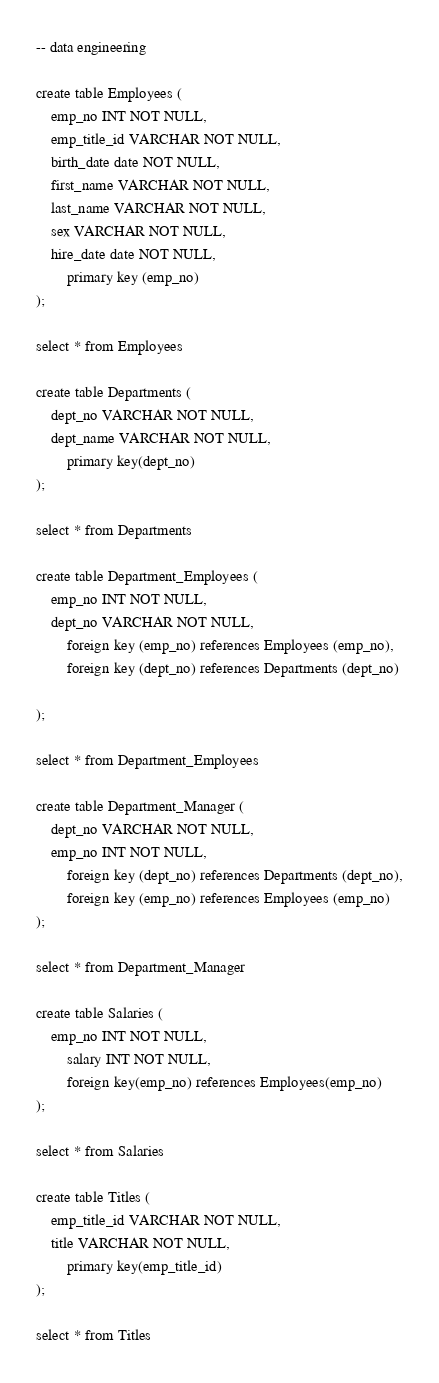Convert code to text. <code><loc_0><loc_0><loc_500><loc_500><_SQL_>-- data engineering

create table Employees (
	emp_no INT NOT NULL,
	emp_title_id VARCHAR NOT NULL,
	birth_date date NOT NULL,
	first_name VARCHAR NOT NULL,
	last_name VARCHAR NOT NULL,
	sex VARCHAR NOT NULL,
	hire_date date NOT NULL,
		primary key (emp_no)
);

select * from Employees

create table Departments (
	dept_no VARCHAR NOT NULL,
	dept_name VARCHAR NOT NULL,
		primary key(dept_no)
);

select * from Departments

create table Department_Employees (
	emp_no INT NOT NULL,
	dept_no VARCHAR NOT NULL,
		foreign key (emp_no) references Employees (emp_no),
		foreign key (dept_no) references Departments (dept_no)
		
);

select * from Department_Employees

create table Department_Manager (
	dept_no VARCHAR NOT NULL,
	emp_no INT NOT NULL,
		foreign key (dept_no) references Departments (dept_no),
		foreign key (emp_no) references Employees (emp_no)
);

select * from Department_Manager

create table Salaries (
	emp_no INT NOT NULL,
		salary INT NOT NULL,
		foreign key(emp_no) references Employees(emp_no)
);

select * from Salaries

create table Titles (
	emp_title_id VARCHAR NOT NULL,
	title VARCHAR NOT NULL,
		primary key(emp_title_id)
);

select * from Titles
</code> 